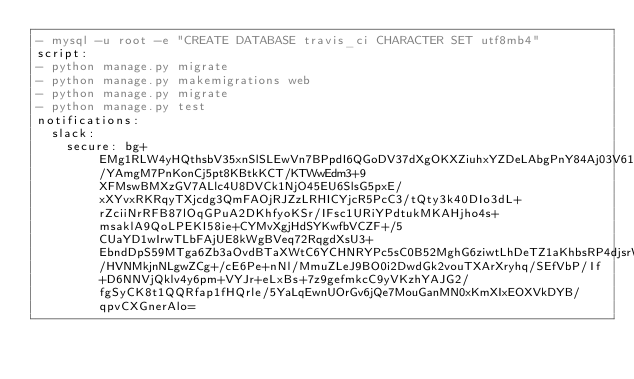Convert code to text. <code><loc_0><loc_0><loc_500><loc_500><_YAML_>- mysql -u root -e "CREATE DATABASE travis_ci CHARACTER SET utf8mb4"
script:
- python manage.py migrate
- python manage.py makemigrations web
- python manage.py migrate
- python manage.py test
notifications:
  slack:
    secure: bg+EMg1RLW4yHQthsbV35xnSlSLEwVn7BPpdI6QGoDV37dXgOKXZiuhxYZDeLAbgPnY84Aj03V61OaBPXJyGcn71DI1UGmmWuBiofVODao/YAmgM7PnKonCj5pt8KBtkKCT/KTWwEdm3+9XFMswBMXzGV7ALlc4U8DVCk1NjO45EU6SlsG5pxE/xXYvxRKRqyTXjcdg3QmFAOjRJZzLRHICYjcR5PcC3/tQty3k40DIo3dL+rZciiNrRFB87lOqGPuA2DKhfyoKSr/IFsc1URiYPdtukMKAHjho4s+msaklA9QoLPEKI58ie+CYMvXgjHdSYKwfbVCZF+/5CUaYD1wIrwTLbFAjUE8kWgBVeq72RqgdXsU3+EbndDpS59MTga6Zb3aOvdBTaXWtC6YCHNRYPc5sC0B52MghG6ziwtLhDeTZ1aKhbsRP4djsrW4ZL8txMGTTv3Sx8UBGYvkGLk0BrPdUabmpe8fYduNI8/HVNMkjnNLgwZCg+/cE6Pe+nNl/MmuZLeJ9BO0i2DwdGk2vouTXArXryhq/SEfVbP/If+D6NNVjQklv4y6pm+VYJr+eLxBs+7z9gefmkcC9yVKzhYAJG2/fgSyCK8t1QQRfap1fHQrle/5YaLqEwnUOrGv6jQe7MouGanMN0xKmXIxEOXVkDYB/qpvCXGnerAlo=
</code> 